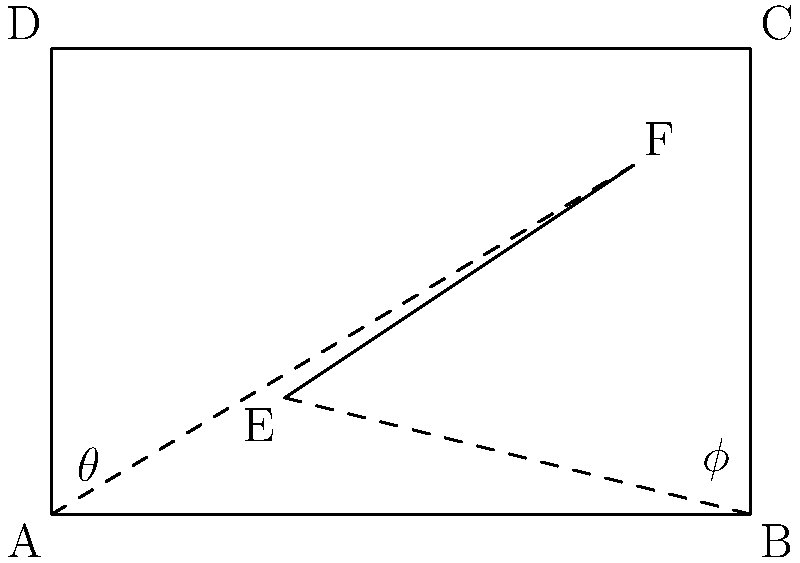In an R-tree structure for spatial indexing, consider a rectangular bounding box ABCD with a diagonal EF. If the angles between the diagonal and the horizontal sides are $\theta$ and $\phi$ as shown, what is the optimal orientation of the bounding box to minimize its area, given that $\tan \theta + \tan \phi = k$, where $k$ is a constant? To find the optimal orientation, we need to minimize the area of the bounding box. Let's approach this step-by-step:

1) The area of the rectangle is given by: $A = width \times height$

2) If we denote the length of the diagonal as $d$, then:
   $width = d \cos \phi$
   $height = d \sin \phi$

3) The area can be expressed as: $A = d^2 \cos \phi \sin \phi$

4) We know that $\sin 2\phi = 2\sin \phi \cos \phi$, so:
   $A = \frac{1}{2}d^2 \sin 2\phi$

5) We need to maximize $\sin 2\phi$ to minimize the area (since $d$ is constant).

6) Given: $\tan \theta + \tan \phi = k$

7) We can express $\tan \theta$ in terms of $\tan \phi$:
   $\tan \theta = k - \tan \phi$

8) Using the tangent addition formula:
   $\tan (\theta + \phi) = \frac{\tan \theta + \tan \phi}{1 - \tan \theta \tan \phi} = \frac{k}{1 - \tan \phi (k - \tan \phi)}$

9) For the area to be minimum, $\theta + \phi$ should be 45°, because $\sin 2(45°) = 1$, which is the maximum value of $\sin 2\phi$.

10) When $\theta + \phi = 45°$, $\tan (\theta + \phi) = 1$

11) Solving the equation:
    $\frac{k}{1 - \tan \phi (k - \tan \phi)} = 1$

12) This simplifies to: $\tan^2 \phi - k \tan \phi + 1 = 0$

13) The solution to this quadratic equation is:
    $\tan \phi = \frac{k \pm \sqrt{k^2 - 4}}{2}$

14) The optimal angle $\phi$ is given by:
    $\phi = \arctan(\frac{k \pm \sqrt{k^2 - 4}}{2})$

Therefore, the optimal orientation is achieved when the angle $\phi$ satisfies this equation.
Answer: $\phi = \arctan(\frac{k \pm \sqrt{k^2 - 4}}{2})$ 